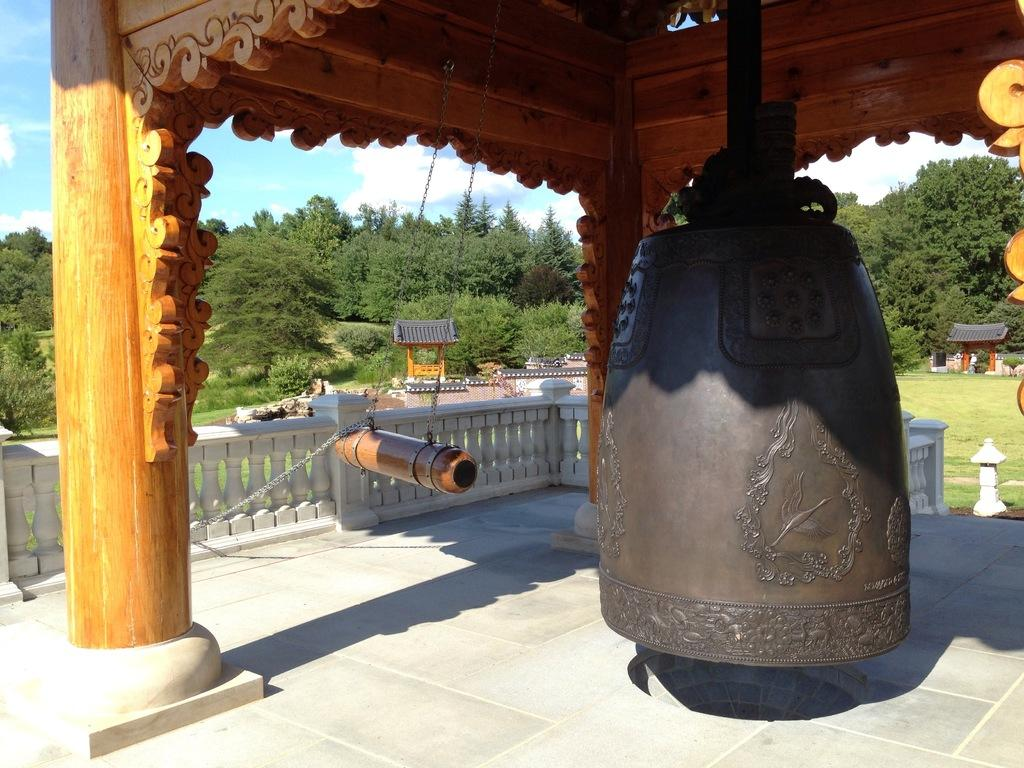What architectural feature can be seen in the image? There are balusters in the image. What large object is present in the image? There is a giant bell in the image. What musical instrument is hanging from a wooden object in the image? A gong is hanging from a wooden object in the image. What type of structures can be seen in the image? There are shelters in the image. What type of vegetation is visible in the image? There are trees in the image. What is visible in the background of the image? The sky is visible in the background of the image. How many wrens are perched on the balusters in the image? There are no wrens present in the image; only balusters, a giant bell, a gong, shelters, trees, and the sky are visible. What type of material is the giant bell made of, and how does it rub against the wooden object in the image? The type of material the giant bell is made of cannot be determined from the image, and there is no wooden object in direct contact with the bell in the image. 